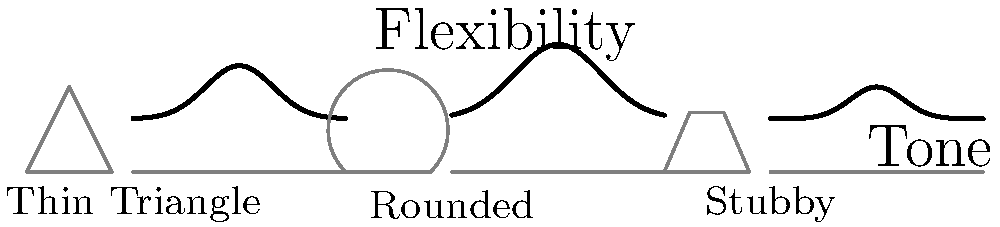As a musician familiar with Warner E. Hodges' guitar techniques, analyze the graph showing how different pick shapes affect flexibility and tone. Which pick shape would likely produce the brightest tone with the least flexibility, potentially suitable for Hodges' energetic playing style? To answer this question, let's analyze the graph step-by-step:

1. The graph shows three different pick shapes: Thin Triangle, Rounded, and Stubby.

2. For each shape, there's a corresponding curve representing flexibility and tone:
   - Higher peak = More flexible
   - Wider curve = Broader tonal range

3. Analyzing each shape:
   a) Thin Triangle: Medium-high flexibility, moderate tonal range
   b) Rounded: Highest flexibility, widest tonal range
   c) Stubby: Lowest flexibility, narrowest tonal range

4. The question asks for the brightest tone with least flexibility:
   - Brighter tones are typically associated with less flexibility
   - The Stubby pick has the lowest, narrowest curve, indicating least flexibility

5. Warner E. Hodges is known for his energetic playing style, which often benefits from picks that offer more control and attack.

6. The Stubby pick's characteristics (least flexible, potentially brighter tone) align well with this playing style.

Therefore, the Stubby pick shape would likely produce the brightest tone with the least flexibility, potentially suiting Hodges' energetic playing style.
Answer: Stubby pick 